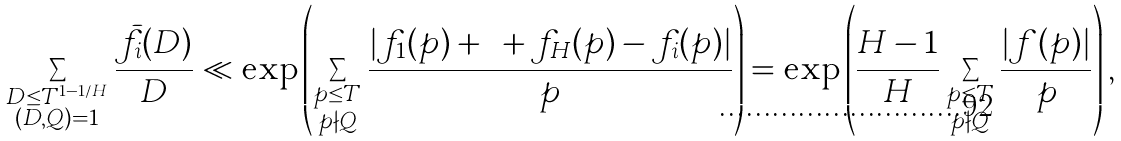Convert formula to latex. <formula><loc_0><loc_0><loc_500><loc_500>\sum _ { \substack { D \leq T ^ { 1 - 1 / H } \\ ( D , Q ) = 1 } } \frac { \bar { f } _ { i } ( D ) } { D } \ll \exp \left ( \sum _ { \substack { p \leq T \\ p \nmid Q } } \frac { | f _ { 1 } ( p ) + \dots + f _ { H } ( p ) - f _ { i } ( p ) | } { p } \right ) = \exp \left ( \frac { H - 1 } { H } \sum _ { \substack { p \leq T \\ p \nmid Q } } \frac { | f ( p ) | } { p } \right ) ,</formula> 